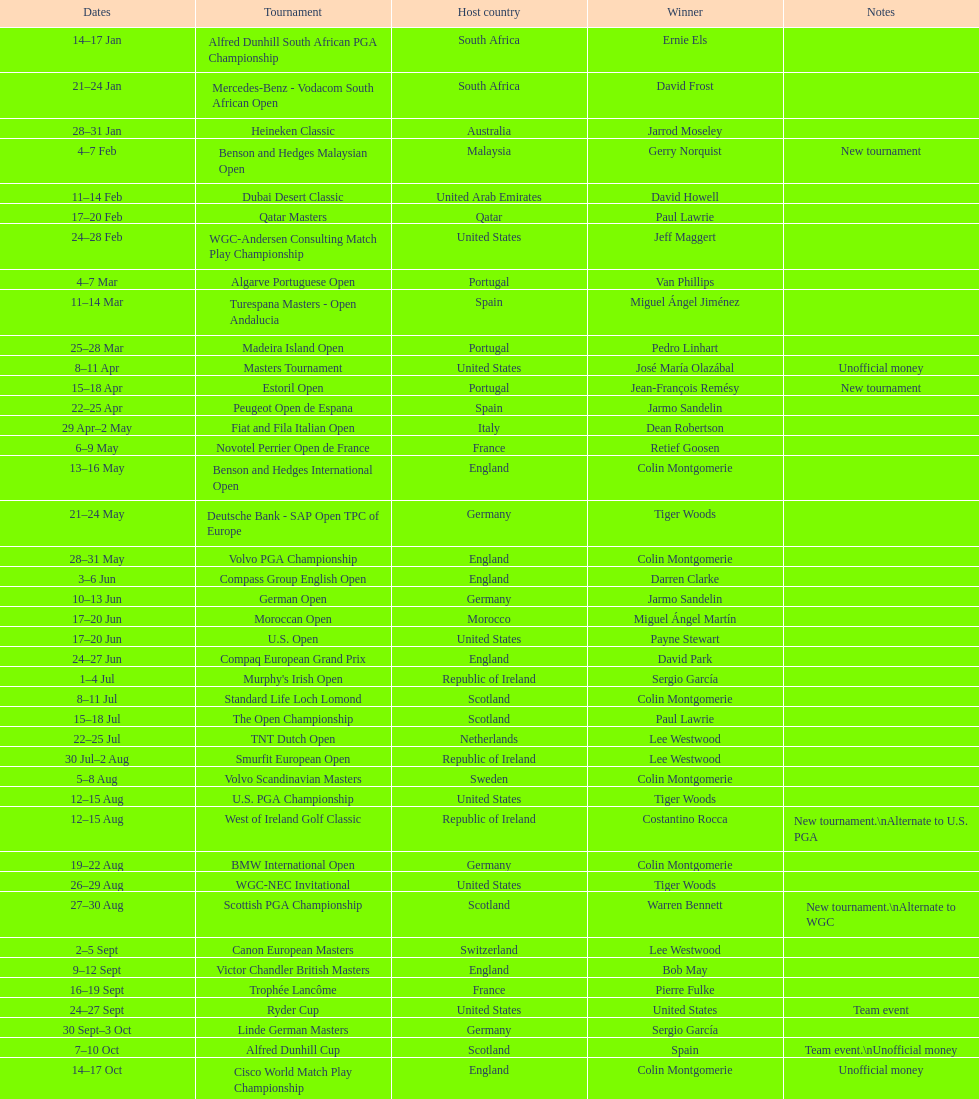Which tournament was later, volvo pga or algarve portuguese open? Volvo PGA. 